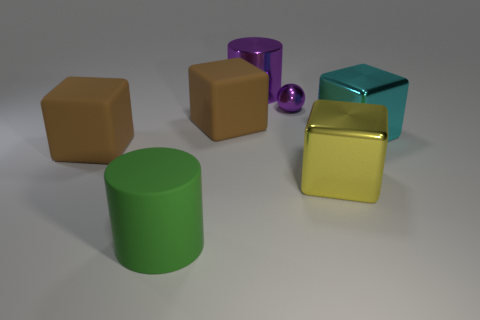How many large cubes have the same color as the small thing?
Give a very brief answer. 0. There is a block that is left of the yellow block and to the right of the green rubber thing; what size is it?
Your response must be concise. Large. Are there fewer spheres that are behind the yellow thing than large cyan blocks?
Give a very brief answer. No. Is the material of the tiny purple ball the same as the yellow cube?
Offer a terse response. Yes. How many objects are either tiny metal objects or cyan cylinders?
Offer a very short reply. 1. How many large purple cylinders are the same material as the cyan cube?
Your answer should be very brief. 1. There is a purple thing that is the same shape as the big green thing; what size is it?
Ensure brevity in your answer.  Large. There is a green cylinder; are there any big cyan metal objects left of it?
Ensure brevity in your answer.  No. What is the material of the small thing?
Provide a succinct answer. Metal. Do the large metal object that is left of the large yellow metallic block and the large rubber cylinder have the same color?
Provide a short and direct response. No. 